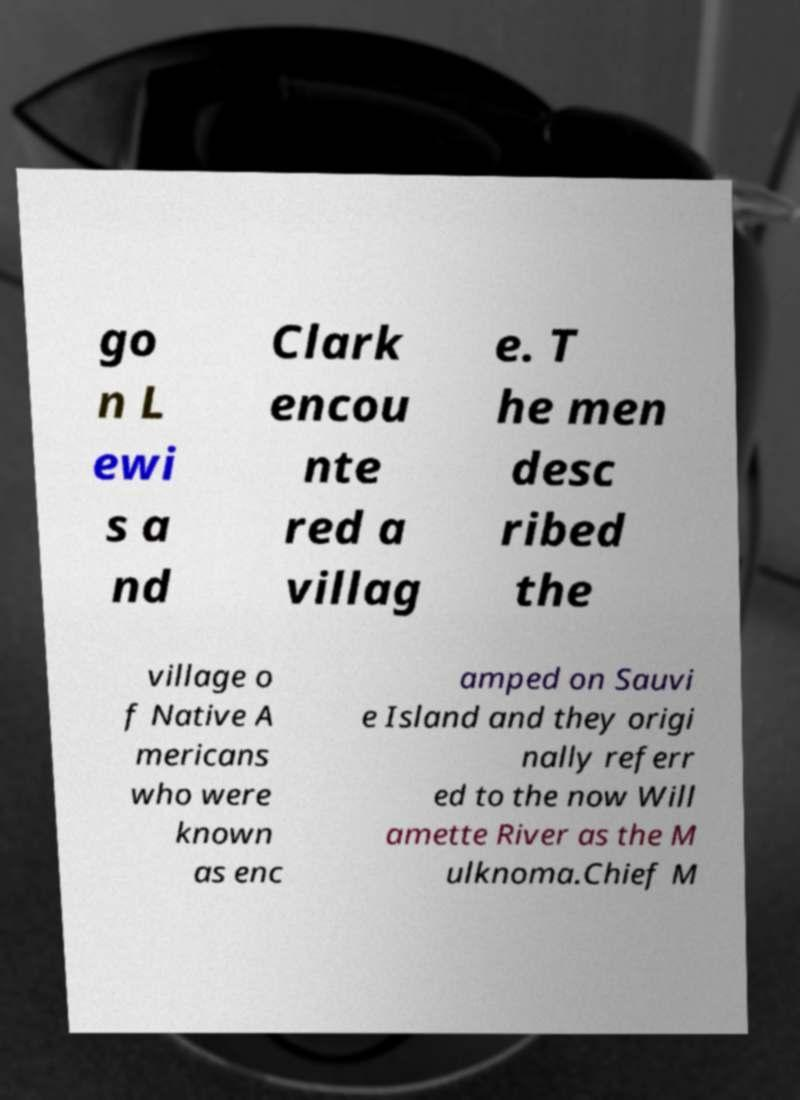Can you read and provide the text displayed in the image?This photo seems to have some interesting text. Can you extract and type it out for me? go n L ewi s a nd Clark encou nte red a villag e. T he men desc ribed the village o f Native A mericans who were known as enc amped on Sauvi e Island and they origi nally referr ed to the now Will amette River as the M ulknoma.Chief M 